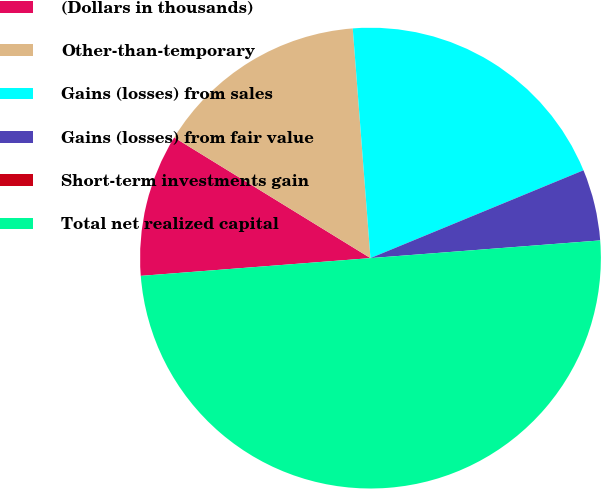<chart> <loc_0><loc_0><loc_500><loc_500><pie_chart><fcel>(Dollars in thousands)<fcel>Other-than-temporary<fcel>Gains (losses) from sales<fcel>Gains (losses) from fair value<fcel>Short-term investments gain<fcel>Total net realized capital<nl><fcel>10.0%<fcel>15.0%<fcel>20.0%<fcel>5.0%<fcel>0.0%<fcel>49.99%<nl></chart> 